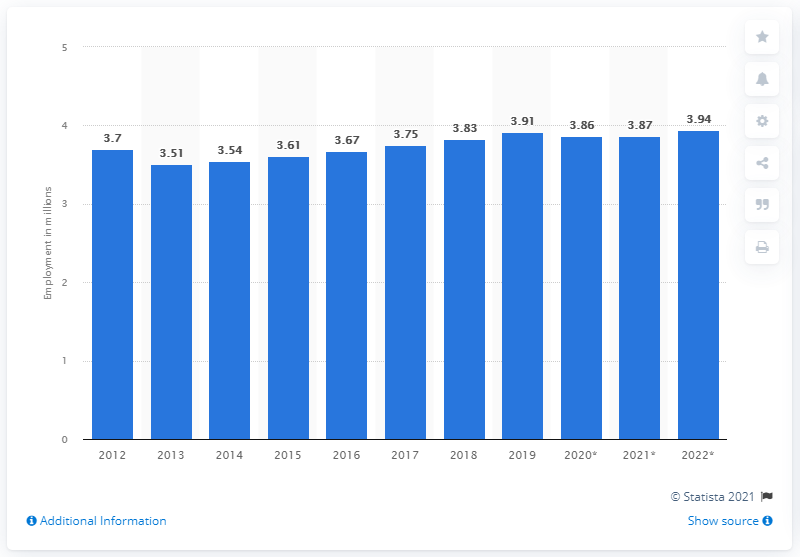Outline some significant characteristics in this image. In 2019, approximately 3.94 million people were employed in Greece. 